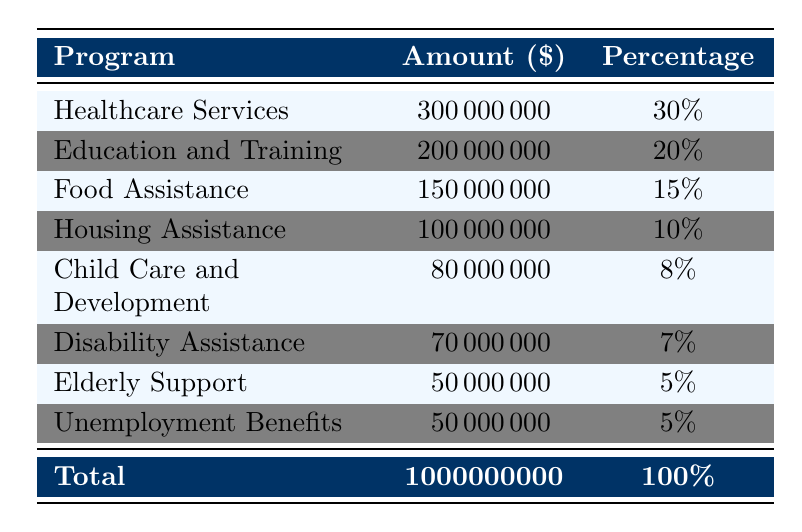What is the total budget allocated for public welfare programs in 2021? The total budget is listed at the bottom of the table in the "Total" row, which states it is 1,000,000,000 dollars.
Answer: 1,000,000,000 How much funding was allocated to Healthcare Services? The table shows that the amount allocated to Healthcare Services is 300,000,000 dollars in the corresponding row.
Answer: 300,000,000 What percentage of the total budget is dedicated to Education and Training? The table indicates that Education and Training received 200,000,000 dollars, which is 20% of the total budget, as noted in the percentage column.
Answer: 20% Is the amount for Disability Assistance greater than the amount for Elderly Support? The table shows that Disability Assistance is allocated 70,000,000 dollars and Elderly Support is allocated 50,000,000 dollars. Since 70,000,000 is greater than 50,000,000, the answer is yes.
Answer: Yes What is the combined funding of Food Assistance and Housing Assistance? Adding the amounts for Food Assistance (150,000,000) and Housing Assistance (100,000,000) gives a total of 250,000,000 dollars. This is calculated by simply summing these two values.
Answer: 250,000,000 What is the percentage of the budget allocated to Child Care and Development compared to the total? The table states that Child Care and Development received 80,000,000 dollars, which is 8% of the total budget. This percentage is directly visible in the percentage column.
Answer: 8% Did the funding for Unemployment Benefits exceed that of Elderly Support? Unemployment Benefits received 50,000,000 dollars, which is equal to the funding for Elderly Support, which also received 50,000,000 dollars. Therefore, the answer is no, as they are equal.
Answer: No Which program received the lowest amount of funding, and how much was it? The smallest allocation can be found by reviewing all the amounts in the table. It is evident that Elderly Support and Unemployment Benefits both received 50,000,000 dollars, but the specific lowest funding in this case pertains to the sub-programs. So, Unemployment Benefits is among the lowest at the program level.
Answer: 50,000,000 What is the average funding amount across all programs listed in the table? The total funding across all programs, excluding individual sub-programs, is 1,000,000,000, and there are 8 main programs listed in the table. To find the average, divide 1,000,000,000 by 8, resulting in 125,000,000 dollars per program.
Answer: 125,000,000 